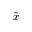<formula> <loc_0><loc_0><loc_500><loc_500>\hat { x }</formula> 